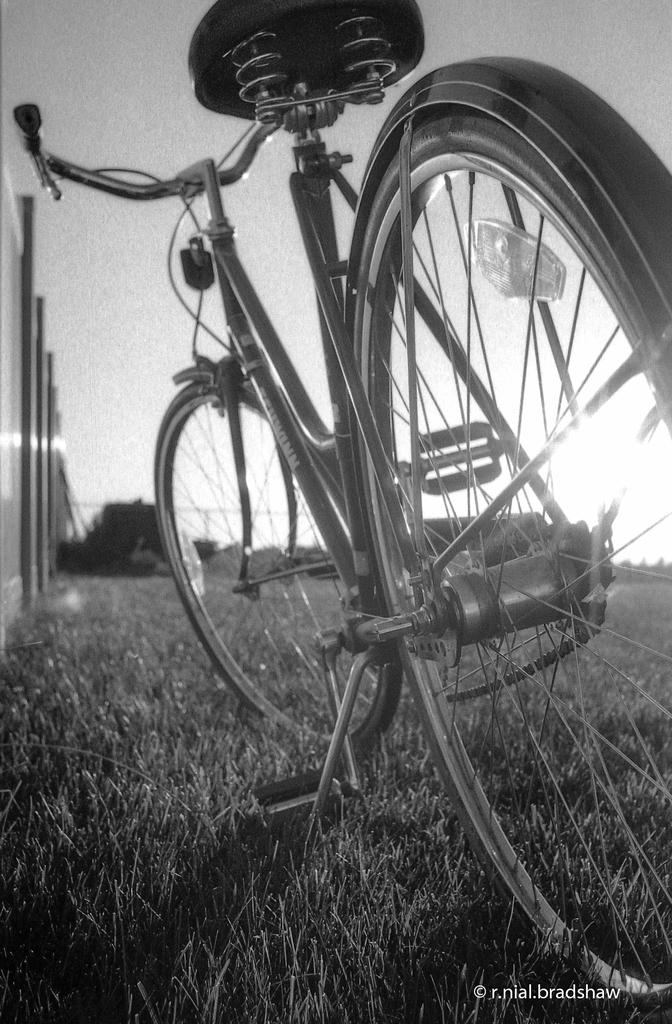What is the main object in the image? There is a bicycle in the image. How is the bicycle positioned in the image? The bicycle is parked on the ground. What type of surface is the bicycle parked on? The ground is covered with grass. What is the color scheme of the image? The image is in black and white color. Can you see any tubs in the image? There are no tubs present in the image. What type of farm animals can be seen grazing in the image? There are no farm animals visible in the image, as it features a bicycle parked on grass. 